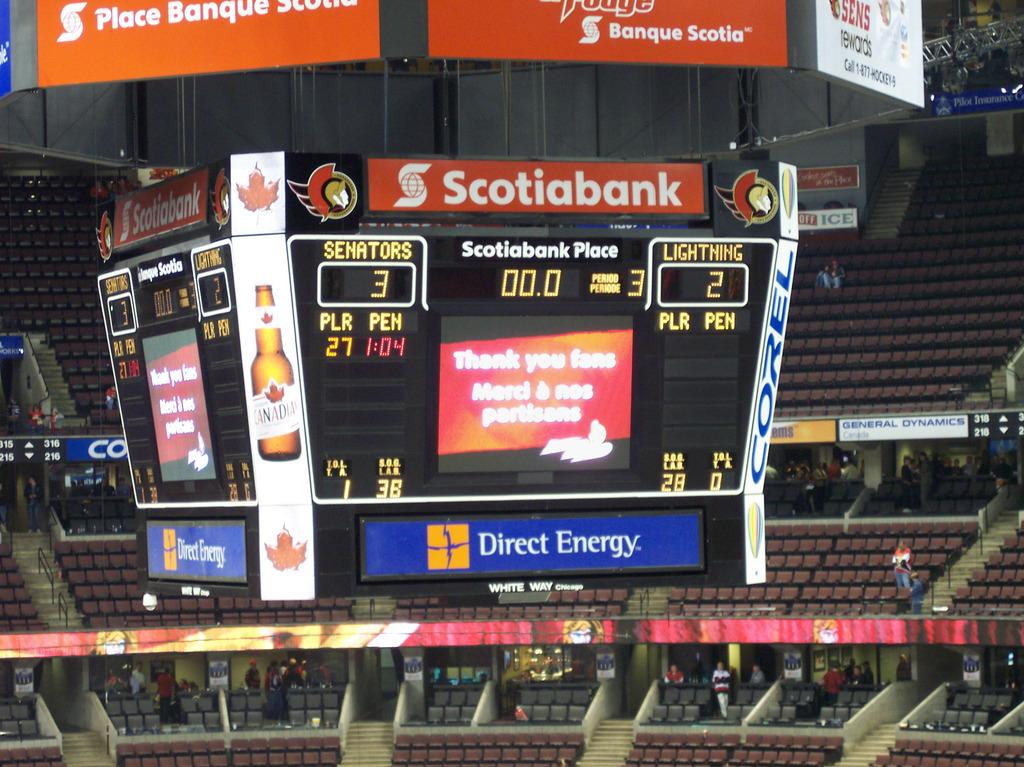<image>
Relay a brief, clear account of the picture shown. Scotiabank has a stadium named after it called Scotiabank Place 